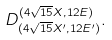Convert formula to latex. <formula><loc_0><loc_0><loc_500><loc_500>D ^ { ( 4 \sqrt { 1 5 } X , 1 2 E ) } _ { ( 4 \sqrt { 1 5 } X ^ { \prime } , 1 2 E ^ { \prime } ) } .</formula> 